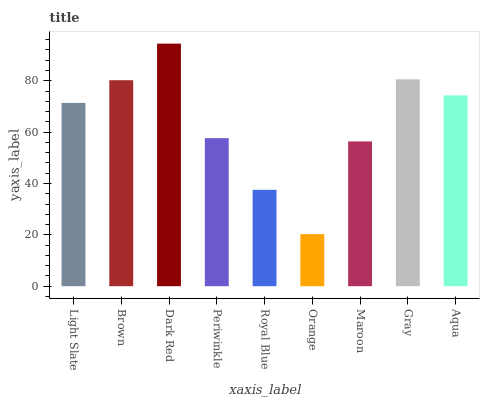Is Orange the minimum?
Answer yes or no. Yes. Is Dark Red the maximum?
Answer yes or no. Yes. Is Brown the minimum?
Answer yes or no. No. Is Brown the maximum?
Answer yes or no. No. Is Brown greater than Light Slate?
Answer yes or no. Yes. Is Light Slate less than Brown?
Answer yes or no. Yes. Is Light Slate greater than Brown?
Answer yes or no. No. Is Brown less than Light Slate?
Answer yes or no. No. Is Light Slate the high median?
Answer yes or no. Yes. Is Light Slate the low median?
Answer yes or no. Yes. Is Royal Blue the high median?
Answer yes or no. No. Is Dark Red the low median?
Answer yes or no. No. 